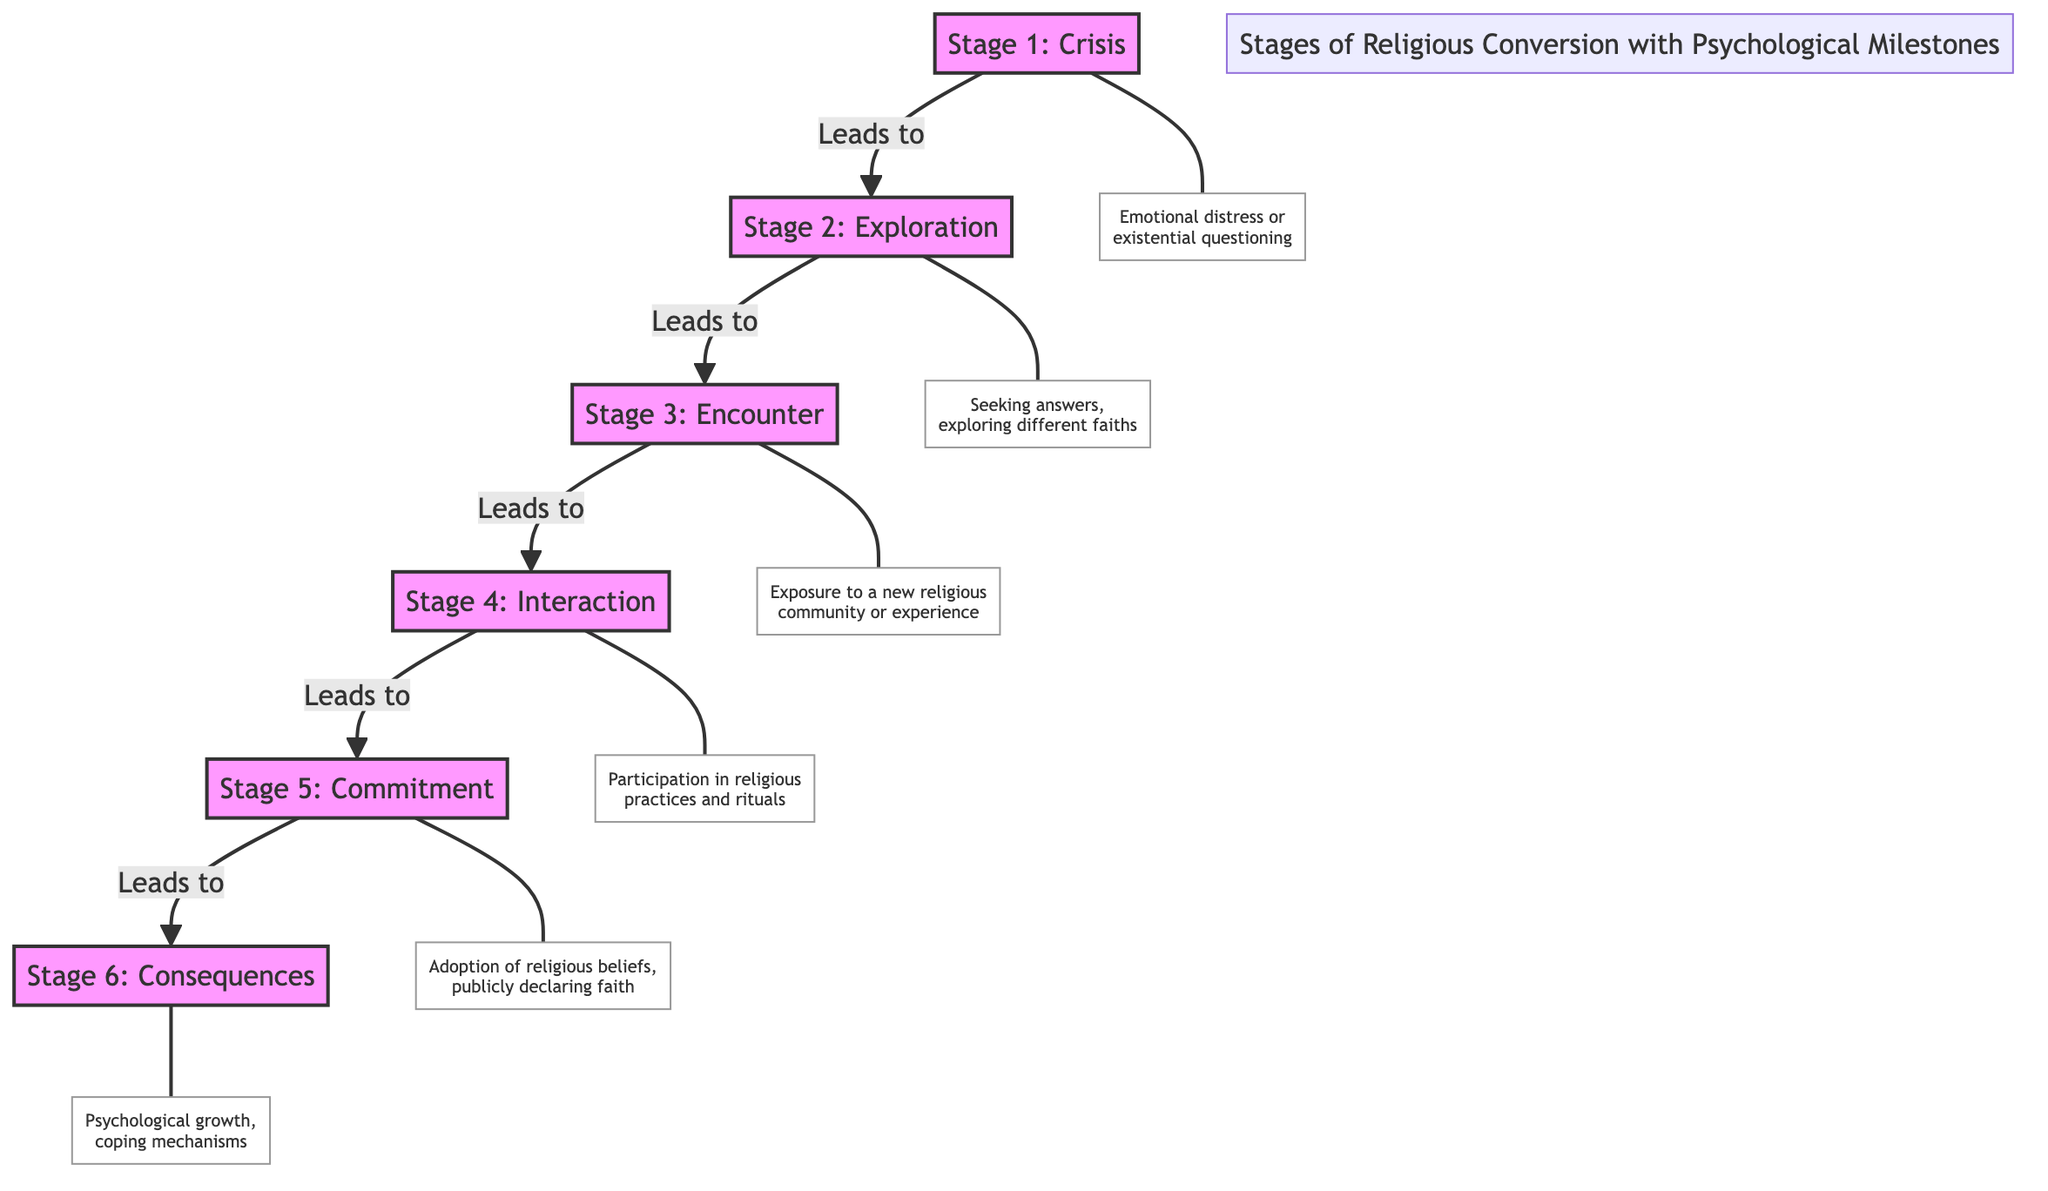What is the first stage of religious conversion? The first stage is labeled "Stage 1: Crisis" in the diagram.
Answer: Stage 1: Crisis How many stages of religious conversion are there? The diagram shows a total of six stages labeled from Stage 1 to Stage 6, making it six stages in total.
Answer: 6 What precedes the "Encounter" stage? By following the arrows in the diagram, it's clear that the "Exploration" stage leads to the "Encounter" stage.
Answer: Exploration Which stage represents the adoption of beliefs? According to the diagram, "Stage 5: Commitment" is associated with the adoption of religious beliefs.
Answer: Stage 5: Commitment What psychological milestone is associated with the "Interaction" stage? The milestone connected to the "Interaction" stage, labeled underneath, is "Participation in religious practices and rituals."
Answer: Participation in religious practices and rituals What is the final stage and its consequence? The final stage is "Stage 6: Consequences," which is linked to the consequence of "Psychological growth, coping mechanisms."
Answer: Psychological growth, coping mechanisms How many psychological milestones are listed in the diagram? There are a total of six psychological milestones, each corresponding to a stage of religious conversion.
Answer: 6 Which stage involves seeking answers? In the diagram, "Stage 2: Exploration" includes the action of seeking answers.
Answer: Stage 2: Exploration What is the relationship between "Crisis" and "Exploration"? The diagram indicates that "Crisis" leads to "Exploration," demonstrating a direct progression from one stage to the next.
Answer: Leads to 